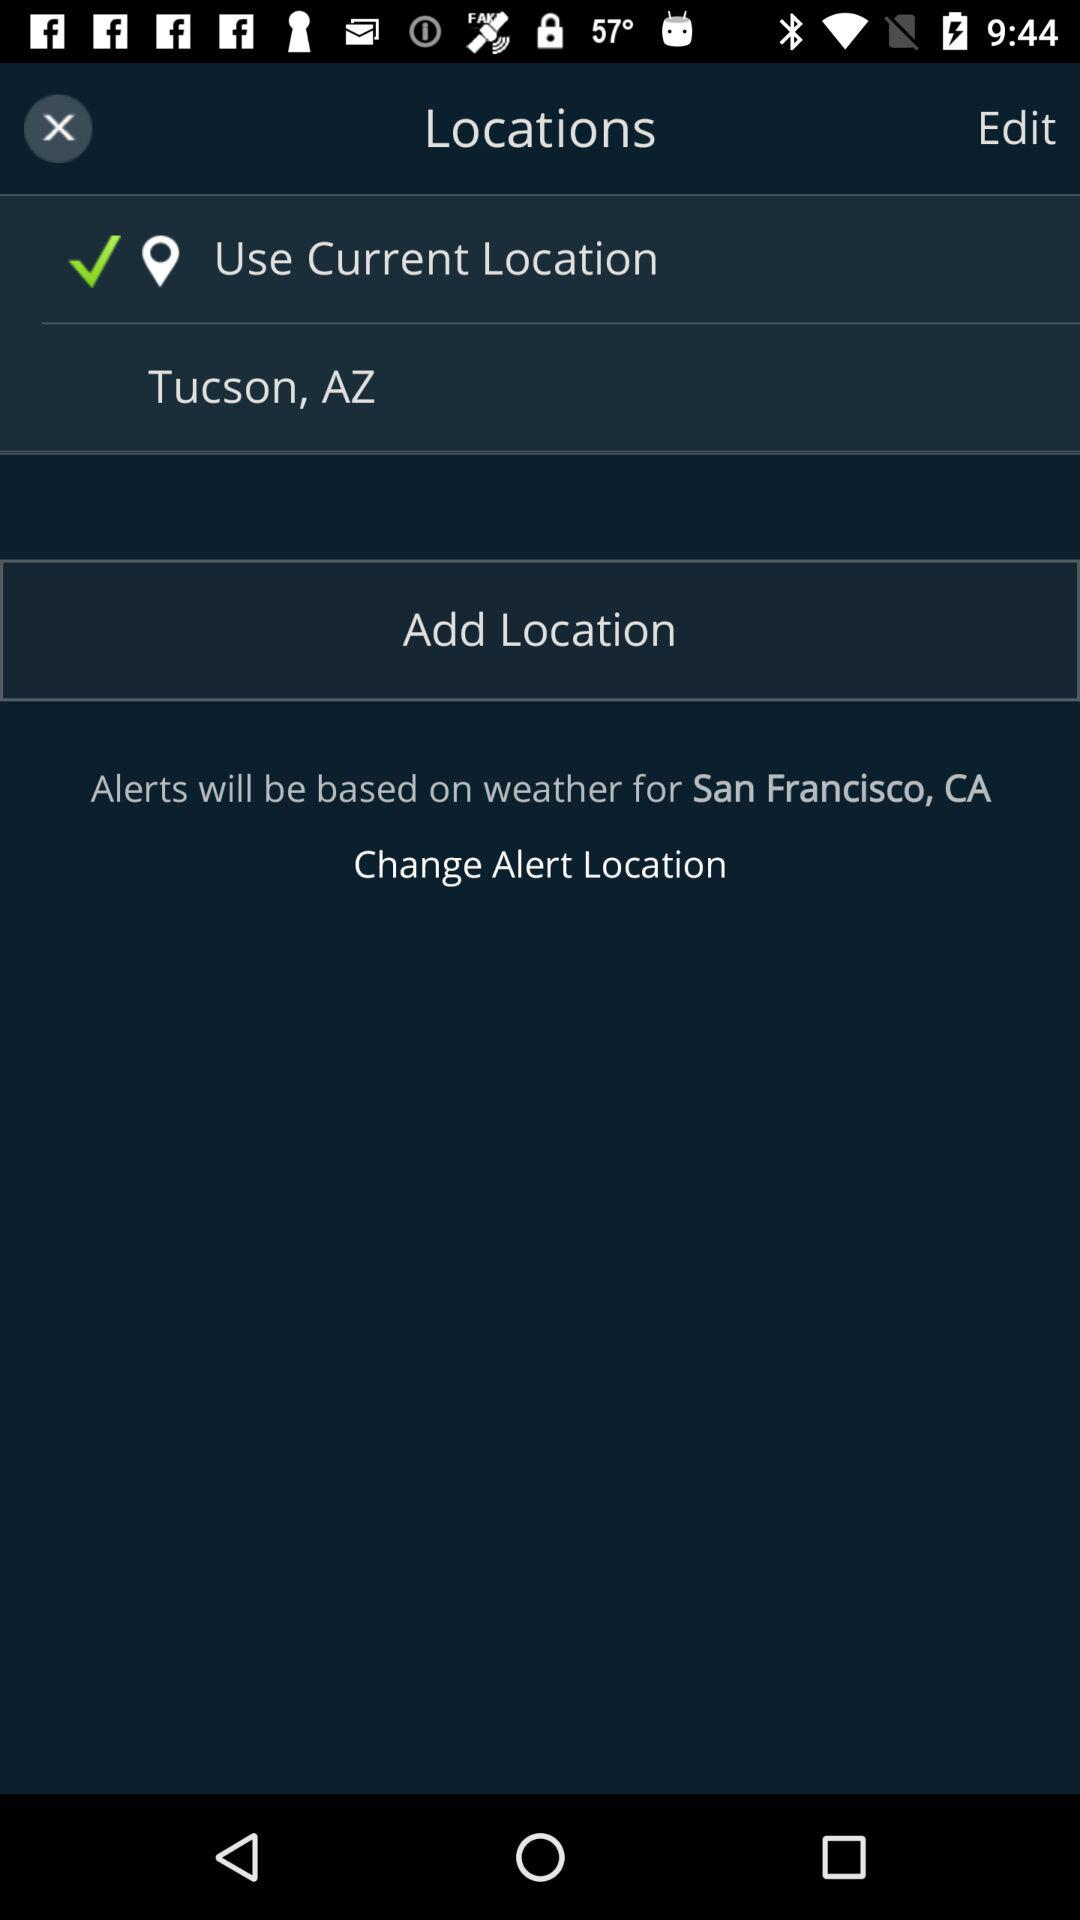What is the suggested location? The suggested location is Tucson, AZ. 